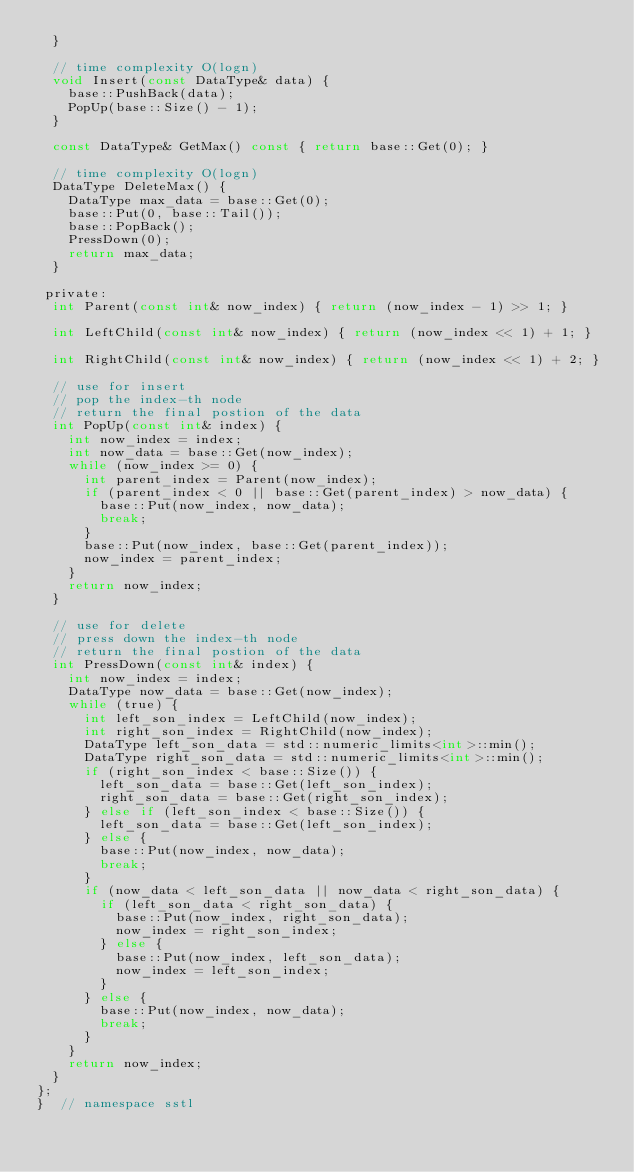<code> <loc_0><loc_0><loc_500><loc_500><_C_>  }

  // time complexity O(logn)
  void Insert(const DataType& data) {
    base::PushBack(data);
    PopUp(base::Size() - 1);
  }

  const DataType& GetMax() const { return base::Get(0); }

  // time complexity O(logn)
  DataType DeleteMax() {
    DataType max_data = base::Get(0);
    base::Put(0, base::Tail());
    base::PopBack();
    PressDown(0);
    return max_data;
  }

 private:
  int Parent(const int& now_index) { return (now_index - 1) >> 1; }

  int LeftChild(const int& now_index) { return (now_index << 1) + 1; }

  int RightChild(const int& now_index) { return (now_index << 1) + 2; }

  // use for insert
  // pop the index-th node
  // return the final postion of the data
  int PopUp(const int& index) {
    int now_index = index;
    int now_data = base::Get(now_index);
    while (now_index >= 0) {
      int parent_index = Parent(now_index);
      if (parent_index < 0 || base::Get(parent_index) > now_data) {
        base::Put(now_index, now_data);
        break;
      }
      base::Put(now_index, base::Get(parent_index));
      now_index = parent_index;
    }
    return now_index;
  }

  // use for delete
  // press down the index-th node
  // return the final postion of the data
  int PressDown(const int& index) {
    int now_index = index;
    DataType now_data = base::Get(now_index);
    while (true) {
      int left_son_index = LeftChild(now_index);
      int right_son_index = RightChild(now_index);
      DataType left_son_data = std::numeric_limits<int>::min();
      DataType right_son_data = std::numeric_limits<int>::min();
      if (right_son_index < base::Size()) {
        left_son_data = base::Get(left_son_index);
        right_son_data = base::Get(right_son_index);
      } else if (left_son_index < base::Size()) {
        left_son_data = base::Get(left_son_index);
      } else {
        base::Put(now_index, now_data);
        break;
      }
      if (now_data < left_son_data || now_data < right_son_data) {
        if (left_son_data < right_son_data) {
          base::Put(now_index, right_son_data);
          now_index = right_son_index;
        } else {
          base::Put(now_index, left_son_data);
          now_index = left_son_index;
        }
      } else {
        base::Put(now_index, now_data);
        break;
      }
    }
    return now_index;
  }
};
}  // namespace sstl
</code> 